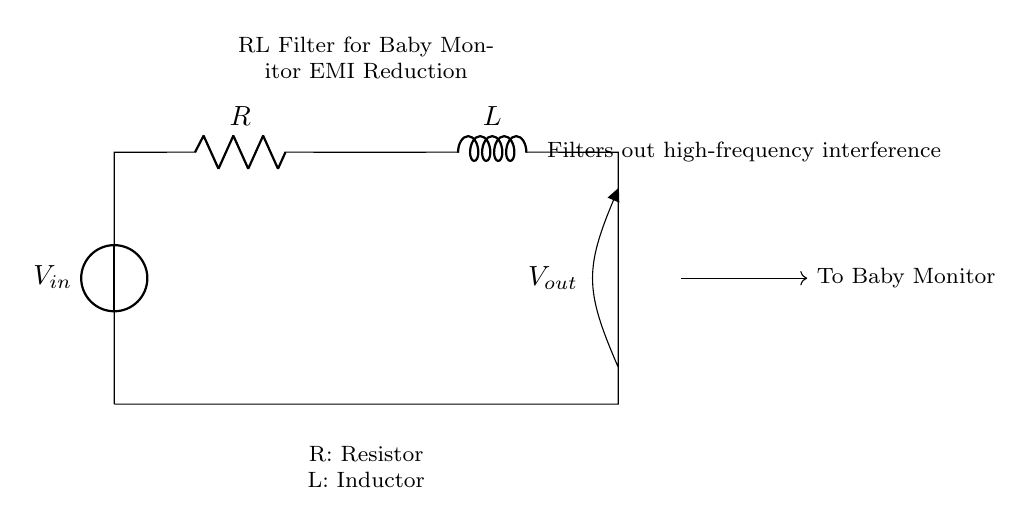What are the components of this circuit? The circuit contains a voltage source, a resistor, and an inductor, which are standard components in an RL filter circuit.
Answer: voltage source, resistor, inductor What is the purpose of the inductor in this circuit? The inductor is used to filter out high-frequency electromagnetic interference by opposing changes in current.
Answer: filter EMI What type of filter is represented in this circuit? This is an RL filter circuit specifically designed for reducing electromagnetic interference in baby monitors.
Answer: RL filter What is the output voltage labeled as in the circuit? The output voltage is labeled as V out, indicating where the filtered voltage is taken.
Answer: V out What does the circuit do with high-frequency interference? The circuit reduces or filters out high-frequency interference to provide a cleaner signal to the baby monitor.
Answer: reduces interference What is the relationship between the resistor and the inductor in this circuit? The resistor and inductor are in series, and together they create a time constant that affects the filter's response to signals.
Answer: in series How does the connection to the baby monitor affect the circuit operation? The connection to the baby monitor receives the filtered output, which ensures clear audio without interference from high-frequency noise.
Answer: filters audio signal 